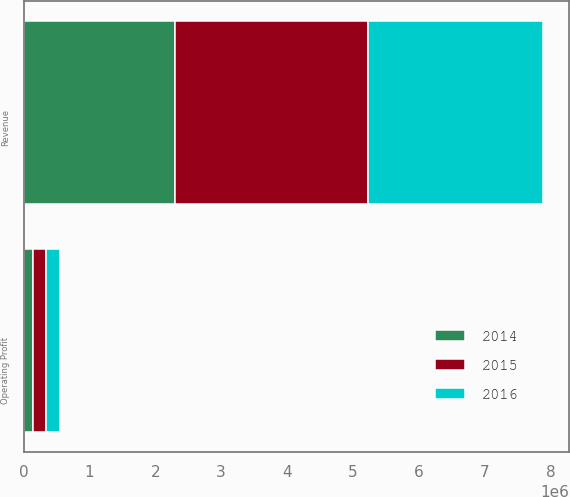Convert chart to OTSL. <chart><loc_0><loc_0><loc_500><loc_500><stacked_bar_chart><ecel><fcel>Revenue<fcel>Operating Profit<nl><fcel>2016<fcel>2.65743e+06<fcel>203808<nl><fcel>2015<fcel>2.92475e+06<fcel>205368<nl><fcel>2014<fcel>2.30645e+06<fcel>139684<nl></chart> 